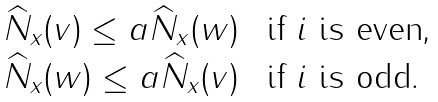Convert formula to latex. <formula><loc_0><loc_0><loc_500><loc_500>\begin{array} { l l } \widehat { N } _ { x } ( v ) \leq a \widehat { N } _ { x } ( w ) & \text { if $i$ is even,} \\ \widehat { N } _ { x } ( w ) \leq a \widehat { N } _ { x } ( v ) & \text { if $i$ is odd} . \end{array}</formula> 